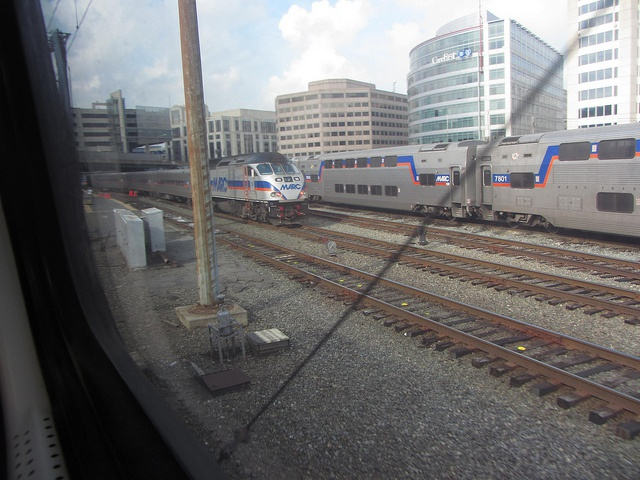Describe the objects in this image and their specific colors. I can see train in black, darkgray, gray, and lightgray tones and train in black, gray, darkgray, and lightgray tones in this image. 